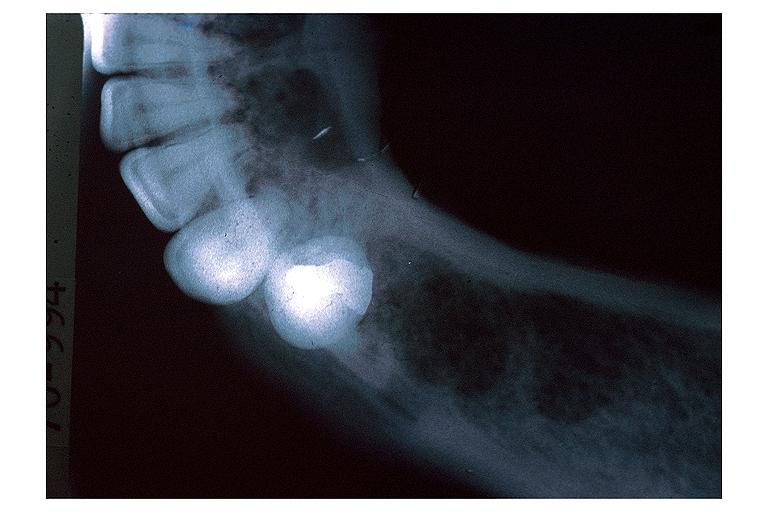what does this image show?
Answer the question using a single word or phrase. Lymphoma 